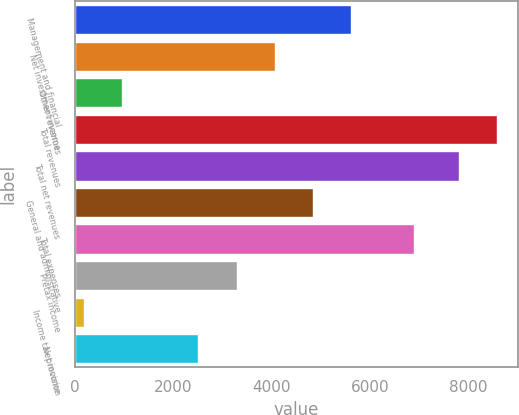Convert chart. <chart><loc_0><loc_0><loc_500><loc_500><bar_chart><fcel>Management and financial<fcel>Net investment income<fcel>Other revenues<fcel>Total revenues<fcel>Total net revenues<fcel>General and administrative<fcel>Total expenses<fcel>Pretax income<fcel>Income tax provision<fcel>Net income<nl><fcel>5617.1<fcel>4064.5<fcel>959.3<fcel>8581.3<fcel>7805<fcel>4840.8<fcel>6885<fcel>3288.2<fcel>183<fcel>2511.9<nl></chart> 